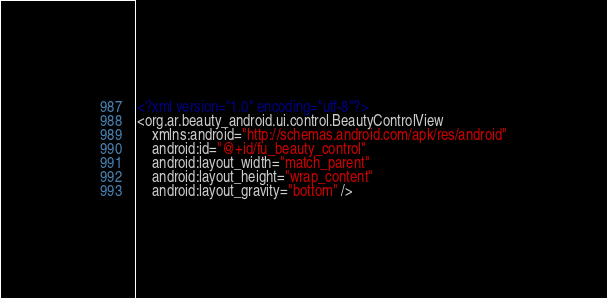Convert code to text. <code><loc_0><loc_0><loc_500><loc_500><_XML_><?xml version="1.0" encoding="utf-8"?>
<org.ar.beauty_android.ui.control.BeautyControlView
    xmlns:android="http://schemas.android.com/apk/res/android"
    android:id="@+id/fu_beauty_control"
    android:layout_width="match_parent"
    android:layout_height="wrap_content"
    android:layout_gravity="bottom" />
</code> 